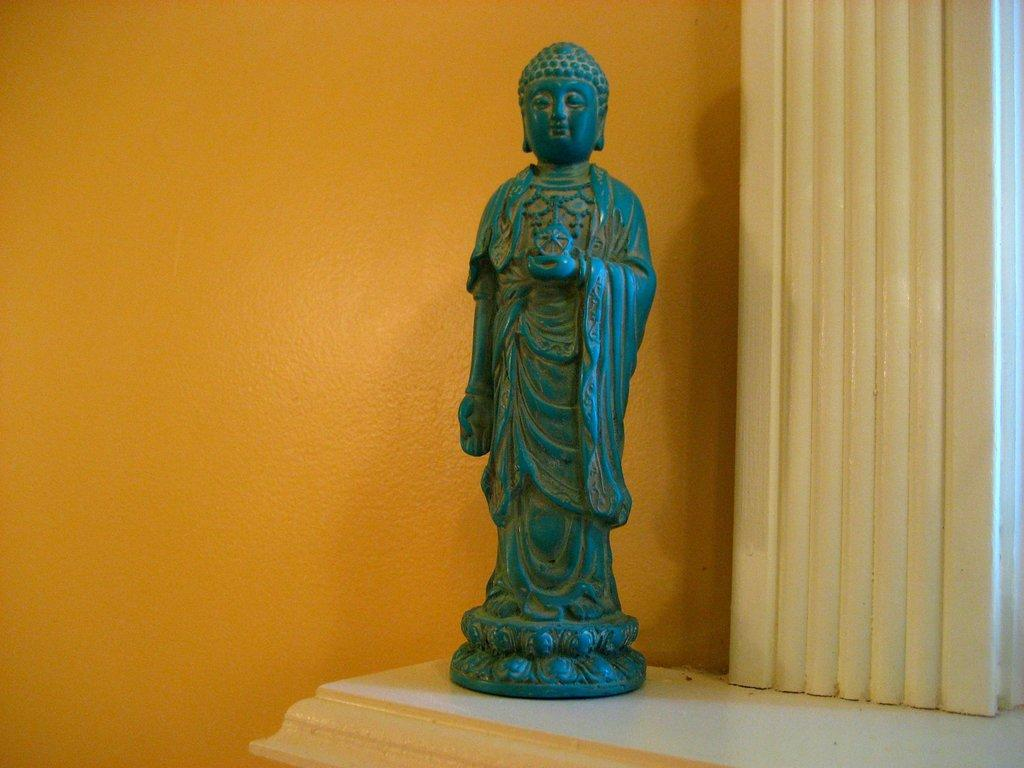What is the main subject in the center of the image? There is a statue in the center of the image. What can be seen in the background of the image? There is a wall in the background of the image. What is located at the bottom of the image? There appears to be a table at the bottom of the image. What other architectural feature is present in the image? There is a pillar on the right side of the image. What type of government is depicted in the statue in the image? The image does not depict a government or any political figures; it features a statue as the main subject. 